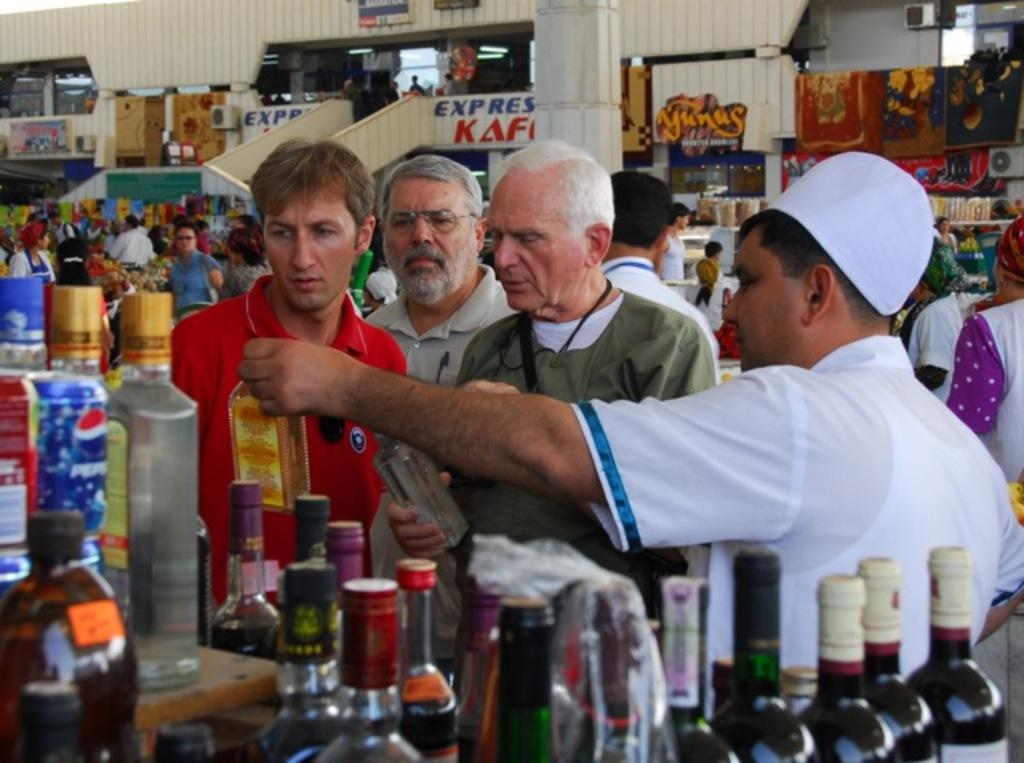What type of location is depicted in the image? There is a market in the image. How many people are present in the market? There is a crowd of people in the market. Can you describe the group of people in the center of the image? There are four people standing in the center of the image. What objects can be seen at the bottom of the image? There are bottles visible at the bottom of the image. What type of birds can be seen flying over the market in the image? There are no birds visible in the image; it only shows a market with people and bottles. 